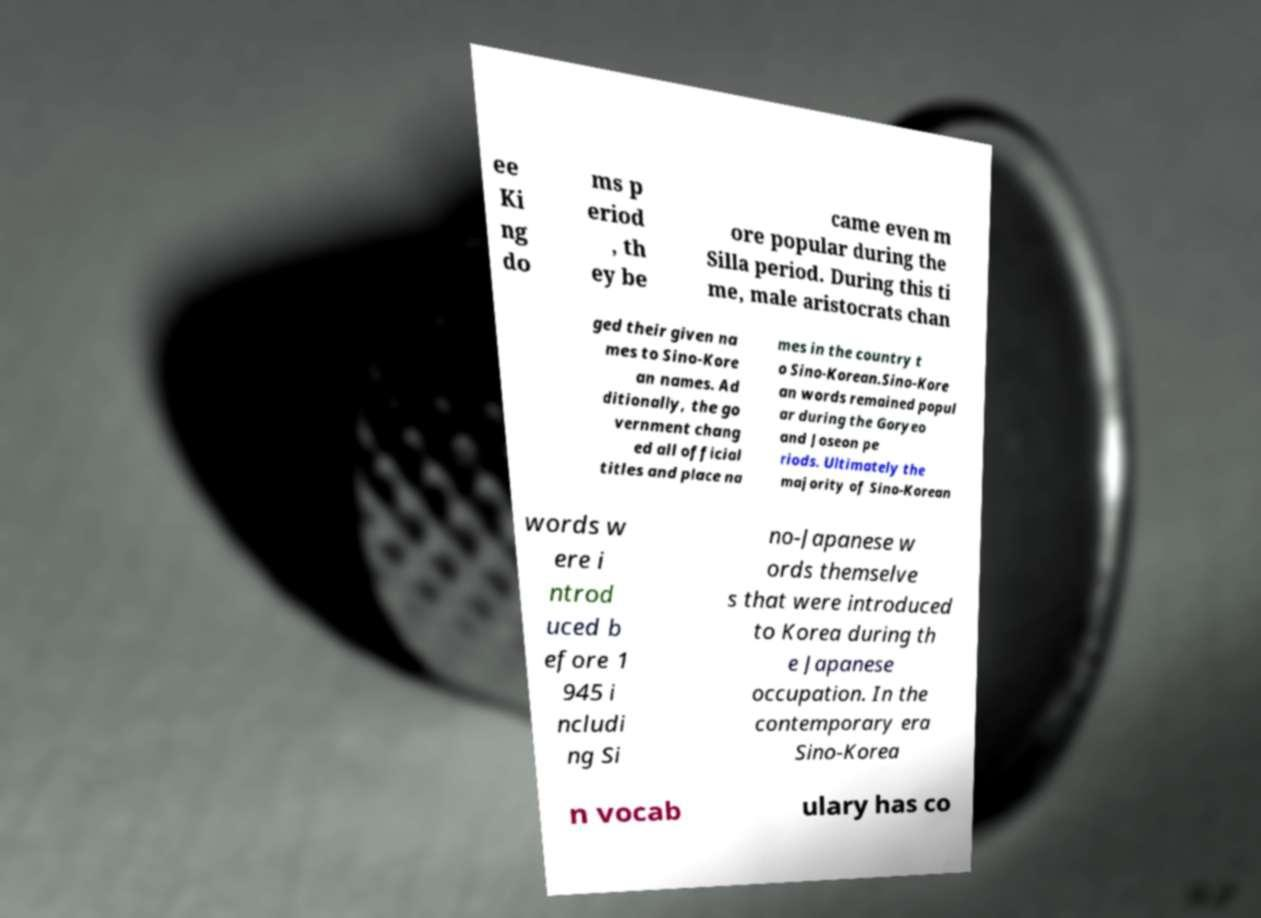What messages or text are displayed in this image? I need them in a readable, typed format. ee Ki ng do ms p eriod , th ey be came even m ore popular during the Silla period. During this ti me, male aristocrats chan ged their given na mes to Sino-Kore an names. Ad ditionally, the go vernment chang ed all official titles and place na mes in the country t o Sino-Korean.Sino-Kore an words remained popul ar during the Goryeo and Joseon pe riods. Ultimately the majority of Sino-Korean words w ere i ntrod uced b efore 1 945 i ncludi ng Si no-Japanese w ords themselve s that were introduced to Korea during th e Japanese occupation. In the contemporary era Sino-Korea n vocab ulary has co 